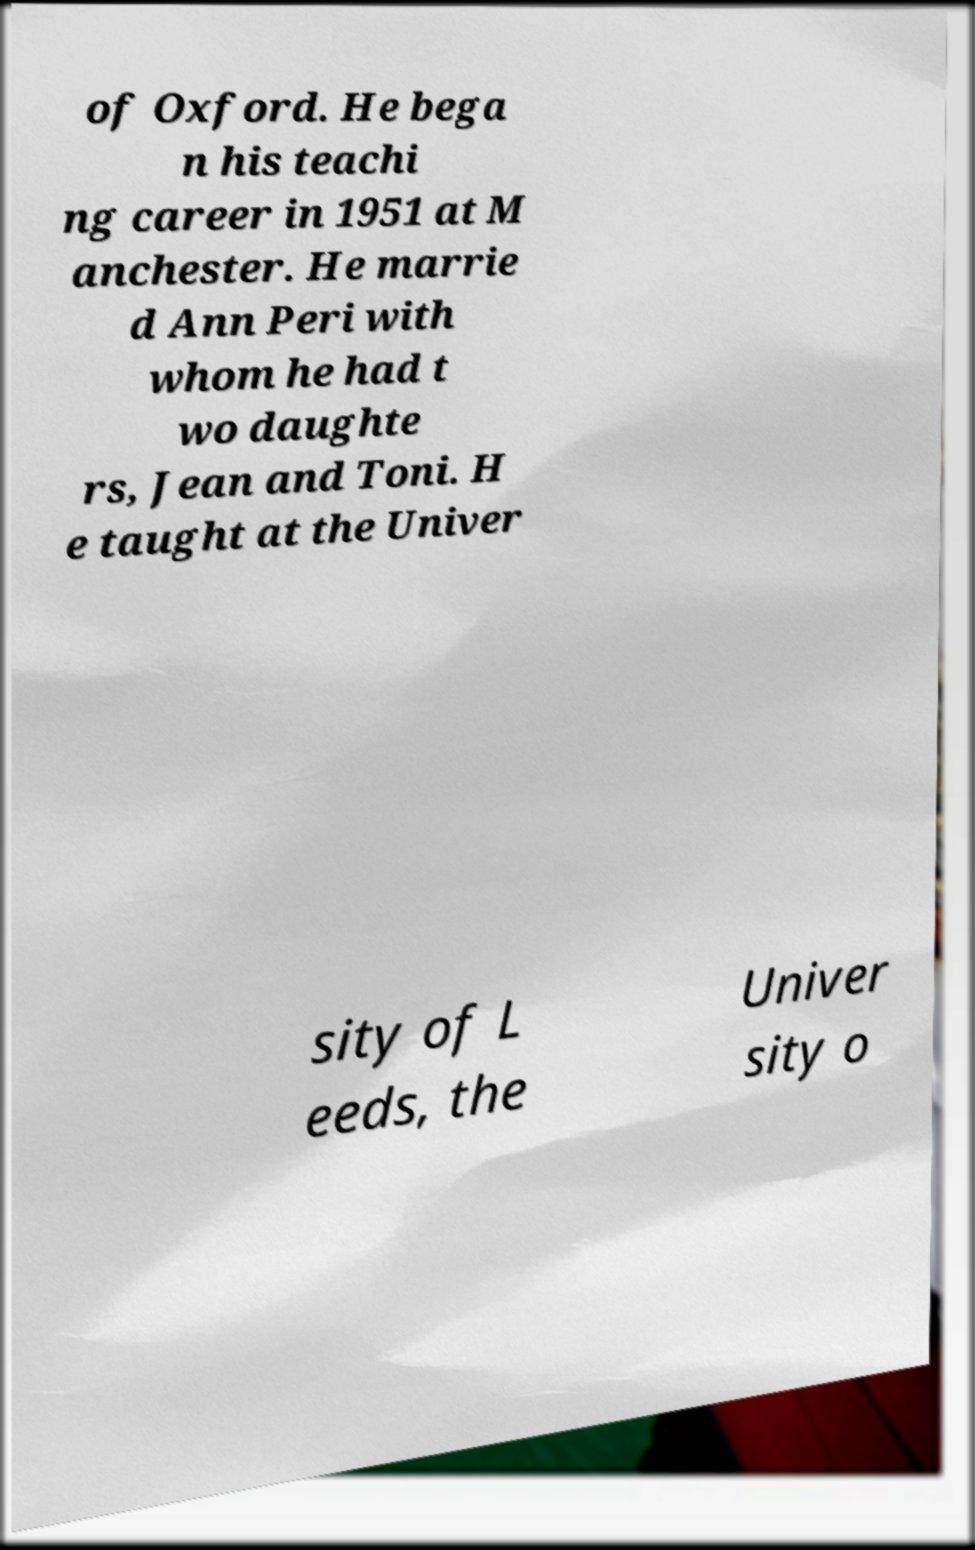Can you accurately transcribe the text from the provided image for me? of Oxford. He bega n his teachi ng career in 1951 at M anchester. He marrie d Ann Peri with whom he had t wo daughte rs, Jean and Toni. H e taught at the Univer sity of L eeds, the Univer sity o 